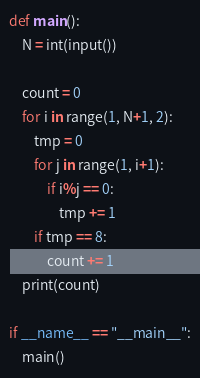Convert code to text. <code><loc_0><loc_0><loc_500><loc_500><_Python_>def main():
    N = int(input())

    count = 0
    for i in range(1, N+1, 2):
        tmp = 0
        for j in range(1, i+1):
            if i%j == 0:
                tmp += 1
        if tmp == 8:
            count += 1
    print(count)

if __name__ == "__main__":
    main()</code> 